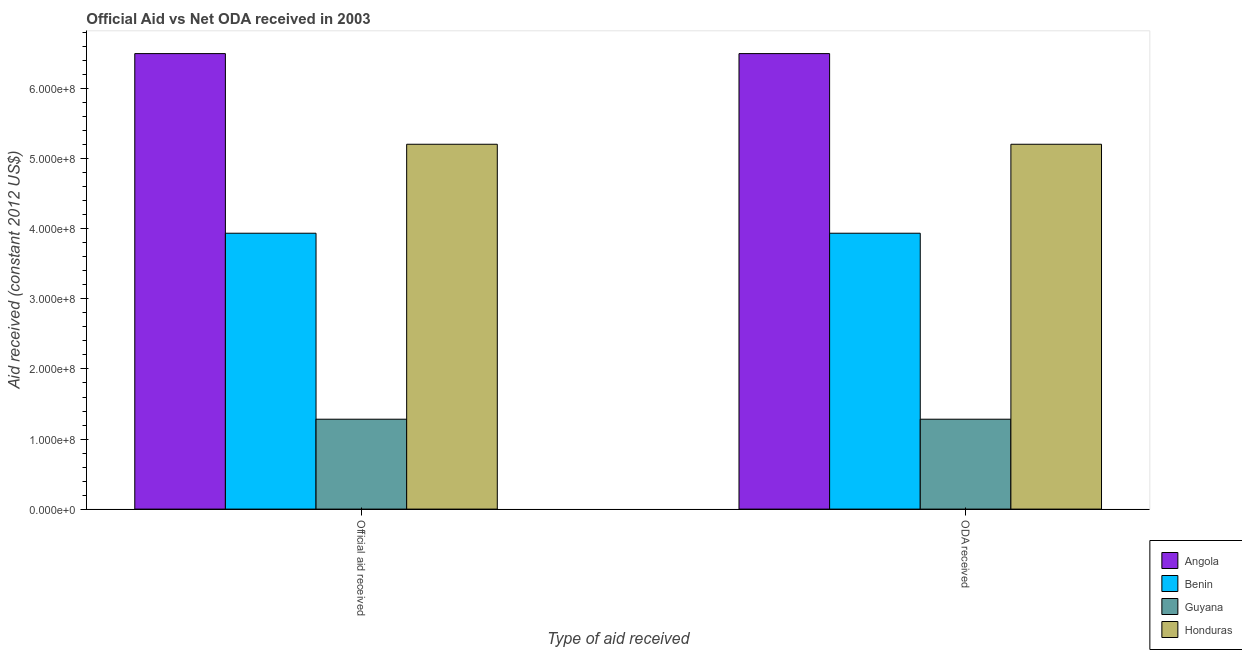Are the number of bars per tick equal to the number of legend labels?
Offer a very short reply. Yes. Are the number of bars on each tick of the X-axis equal?
Your answer should be compact. Yes. How many bars are there on the 1st tick from the left?
Ensure brevity in your answer.  4. What is the label of the 1st group of bars from the left?
Your response must be concise. Official aid received. What is the oda received in Benin?
Give a very brief answer. 3.94e+08. Across all countries, what is the maximum oda received?
Your response must be concise. 6.50e+08. Across all countries, what is the minimum official aid received?
Your answer should be compact. 1.28e+08. In which country was the official aid received maximum?
Your answer should be very brief. Angola. In which country was the official aid received minimum?
Your answer should be very brief. Guyana. What is the total oda received in the graph?
Your answer should be compact. 1.69e+09. What is the difference between the oda received in Benin and that in Guyana?
Ensure brevity in your answer.  2.65e+08. What is the difference between the oda received in Angola and the official aid received in Guyana?
Ensure brevity in your answer.  5.22e+08. What is the average oda received per country?
Offer a very short reply. 4.23e+08. What is the difference between the oda received and official aid received in Guyana?
Make the answer very short. 0. What is the ratio of the oda received in Angola to that in Benin?
Keep it short and to the point. 1.65. In how many countries, is the official aid received greater than the average official aid received taken over all countries?
Keep it short and to the point. 2. What does the 4th bar from the left in Official aid received represents?
Make the answer very short. Honduras. What does the 1st bar from the right in Official aid received represents?
Your answer should be compact. Honduras. Are all the bars in the graph horizontal?
Offer a terse response. No. Does the graph contain any zero values?
Keep it short and to the point. No. How many legend labels are there?
Provide a short and direct response. 4. What is the title of the graph?
Provide a succinct answer. Official Aid vs Net ODA received in 2003 . Does "Mexico" appear as one of the legend labels in the graph?
Offer a terse response. No. What is the label or title of the X-axis?
Offer a very short reply. Type of aid received. What is the label or title of the Y-axis?
Ensure brevity in your answer.  Aid received (constant 2012 US$). What is the Aid received (constant 2012 US$) in Angola in Official aid received?
Your answer should be very brief. 6.50e+08. What is the Aid received (constant 2012 US$) in Benin in Official aid received?
Make the answer very short. 3.94e+08. What is the Aid received (constant 2012 US$) in Guyana in Official aid received?
Your answer should be very brief. 1.28e+08. What is the Aid received (constant 2012 US$) in Honduras in Official aid received?
Give a very brief answer. 5.21e+08. What is the Aid received (constant 2012 US$) of Angola in ODA received?
Keep it short and to the point. 6.50e+08. What is the Aid received (constant 2012 US$) in Benin in ODA received?
Provide a short and direct response. 3.94e+08. What is the Aid received (constant 2012 US$) of Guyana in ODA received?
Keep it short and to the point. 1.28e+08. What is the Aid received (constant 2012 US$) of Honduras in ODA received?
Ensure brevity in your answer.  5.21e+08. Across all Type of aid received, what is the maximum Aid received (constant 2012 US$) in Angola?
Your response must be concise. 6.50e+08. Across all Type of aid received, what is the maximum Aid received (constant 2012 US$) in Benin?
Offer a terse response. 3.94e+08. Across all Type of aid received, what is the maximum Aid received (constant 2012 US$) of Guyana?
Provide a succinct answer. 1.28e+08. Across all Type of aid received, what is the maximum Aid received (constant 2012 US$) in Honduras?
Your answer should be compact. 5.21e+08. Across all Type of aid received, what is the minimum Aid received (constant 2012 US$) in Angola?
Your answer should be very brief. 6.50e+08. Across all Type of aid received, what is the minimum Aid received (constant 2012 US$) in Benin?
Offer a very short reply. 3.94e+08. Across all Type of aid received, what is the minimum Aid received (constant 2012 US$) of Guyana?
Offer a terse response. 1.28e+08. Across all Type of aid received, what is the minimum Aid received (constant 2012 US$) of Honduras?
Offer a terse response. 5.21e+08. What is the total Aid received (constant 2012 US$) in Angola in the graph?
Your answer should be compact. 1.30e+09. What is the total Aid received (constant 2012 US$) of Benin in the graph?
Give a very brief answer. 7.88e+08. What is the total Aid received (constant 2012 US$) of Guyana in the graph?
Provide a succinct answer. 2.57e+08. What is the total Aid received (constant 2012 US$) in Honduras in the graph?
Keep it short and to the point. 1.04e+09. What is the difference between the Aid received (constant 2012 US$) in Benin in Official aid received and that in ODA received?
Offer a very short reply. 0. What is the difference between the Aid received (constant 2012 US$) of Angola in Official aid received and the Aid received (constant 2012 US$) of Benin in ODA received?
Your answer should be very brief. 2.56e+08. What is the difference between the Aid received (constant 2012 US$) in Angola in Official aid received and the Aid received (constant 2012 US$) in Guyana in ODA received?
Offer a very short reply. 5.22e+08. What is the difference between the Aid received (constant 2012 US$) of Angola in Official aid received and the Aid received (constant 2012 US$) of Honduras in ODA received?
Your answer should be compact. 1.29e+08. What is the difference between the Aid received (constant 2012 US$) in Benin in Official aid received and the Aid received (constant 2012 US$) in Guyana in ODA received?
Your answer should be compact. 2.65e+08. What is the difference between the Aid received (constant 2012 US$) in Benin in Official aid received and the Aid received (constant 2012 US$) in Honduras in ODA received?
Your response must be concise. -1.27e+08. What is the difference between the Aid received (constant 2012 US$) of Guyana in Official aid received and the Aid received (constant 2012 US$) of Honduras in ODA received?
Provide a succinct answer. -3.92e+08. What is the average Aid received (constant 2012 US$) of Angola per Type of aid received?
Keep it short and to the point. 6.50e+08. What is the average Aid received (constant 2012 US$) in Benin per Type of aid received?
Your answer should be compact. 3.94e+08. What is the average Aid received (constant 2012 US$) in Guyana per Type of aid received?
Ensure brevity in your answer.  1.28e+08. What is the average Aid received (constant 2012 US$) in Honduras per Type of aid received?
Offer a very short reply. 5.21e+08. What is the difference between the Aid received (constant 2012 US$) of Angola and Aid received (constant 2012 US$) of Benin in Official aid received?
Your answer should be very brief. 2.56e+08. What is the difference between the Aid received (constant 2012 US$) in Angola and Aid received (constant 2012 US$) in Guyana in Official aid received?
Give a very brief answer. 5.22e+08. What is the difference between the Aid received (constant 2012 US$) in Angola and Aid received (constant 2012 US$) in Honduras in Official aid received?
Your answer should be compact. 1.29e+08. What is the difference between the Aid received (constant 2012 US$) of Benin and Aid received (constant 2012 US$) of Guyana in Official aid received?
Provide a succinct answer. 2.65e+08. What is the difference between the Aid received (constant 2012 US$) of Benin and Aid received (constant 2012 US$) of Honduras in Official aid received?
Provide a succinct answer. -1.27e+08. What is the difference between the Aid received (constant 2012 US$) of Guyana and Aid received (constant 2012 US$) of Honduras in Official aid received?
Offer a very short reply. -3.92e+08. What is the difference between the Aid received (constant 2012 US$) of Angola and Aid received (constant 2012 US$) of Benin in ODA received?
Offer a very short reply. 2.56e+08. What is the difference between the Aid received (constant 2012 US$) of Angola and Aid received (constant 2012 US$) of Guyana in ODA received?
Offer a very short reply. 5.22e+08. What is the difference between the Aid received (constant 2012 US$) of Angola and Aid received (constant 2012 US$) of Honduras in ODA received?
Ensure brevity in your answer.  1.29e+08. What is the difference between the Aid received (constant 2012 US$) of Benin and Aid received (constant 2012 US$) of Guyana in ODA received?
Your answer should be compact. 2.65e+08. What is the difference between the Aid received (constant 2012 US$) of Benin and Aid received (constant 2012 US$) of Honduras in ODA received?
Ensure brevity in your answer.  -1.27e+08. What is the difference between the Aid received (constant 2012 US$) of Guyana and Aid received (constant 2012 US$) of Honduras in ODA received?
Offer a terse response. -3.92e+08. What is the ratio of the Aid received (constant 2012 US$) of Angola in Official aid received to that in ODA received?
Your answer should be compact. 1. What is the ratio of the Aid received (constant 2012 US$) in Guyana in Official aid received to that in ODA received?
Keep it short and to the point. 1. What is the ratio of the Aid received (constant 2012 US$) in Honduras in Official aid received to that in ODA received?
Give a very brief answer. 1. What is the difference between the highest and the second highest Aid received (constant 2012 US$) in Angola?
Provide a short and direct response. 0. What is the difference between the highest and the second highest Aid received (constant 2012 US$) in Benin?
Provide a succinct answer. 0. What is the difference between the highest and the second highest Aid received (constant 2012 US$) in Guyana?
Ensure brevity in your answer.  0. What is the difference between the highest and the lowest Aid received (constant 2012 US$) in Angola?
Your response must be concise. 0. What is the difference between the highest and the lowest Aid received (constant 2012 US$) of Honduras?
Your answer should be very brief. 0. 